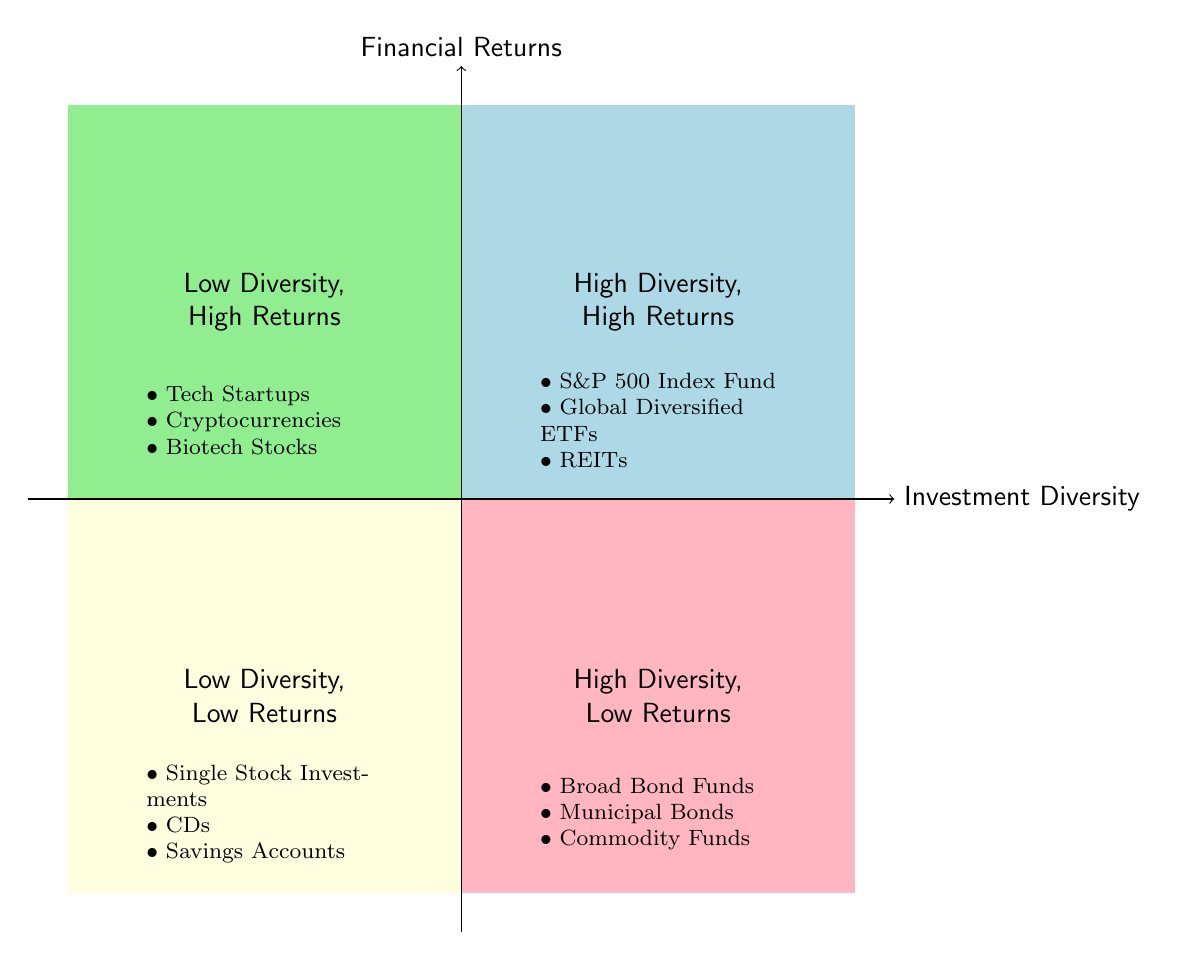What quadrants represent high financial returns? The quadrants with high financial returns are Q1 (High Diversity, High Returns) and Q2 (Low Diversity, High Returns). They are located in the upper half of the chart.
Answer: Q1, Q2 How many examples are listed in Q4? Q4 (High Diversity, Low Returns) lists three examples: Broad Bond Funds, Municipal Bonds, and Commodity Funds. Therefore, the total is three.
Answer: 3 Which quadrant contains tech startups? Tech Startups are an example in Q2, which is designated as Low Diversity, High Returns. This quadrant is located in the upper left section of the chart.
Answer: Q2 What type of investments are in Q3? Q3 contains examples of investments that have Low Diversity and Low Returns, such as Single Stock Investments, Certificates of Deposit, and Savings Accounts.
Answer: Single Stock Investments, CDs, Savings Accounts Which quadrant contains broad bond funds? Broad Bond Funds are listed as an example in Q4, which is the quadrant for High Diversity and Low Returns, situated in the lower right section of the chart.
Answer: Q4 How would you categorize global diversified ETFs? Global Diversified ETFs are categorized in Q1, representing High Diversity and High Returns, which indicates they are effective in balancing both criteria.
Answer: Q1 What is the relationship between diversity and returns in Q2? In Q2, there is Low Diversity but High Returns. This indicates that while the investment options are not diverse, they still yield high financial returns.
Answer: Low Diversity, High Returns How many quadrants show high returns? There are two quadrants that show high returns: Q1 and Q2. Both quadrants are located in the upper half of the diagram.
Answer: 2 